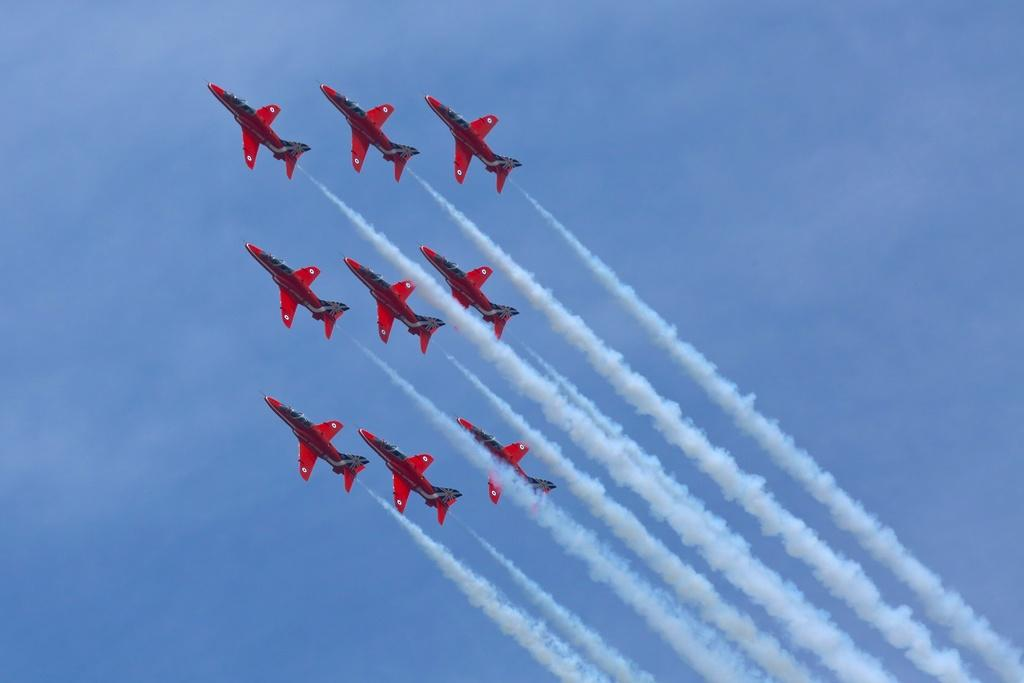What event is taking place in the image? There is an air show in the image. How many aircrafts can be seen during the event? Nine aircrafts are present in the image. What is visible part of the environment is shown in the image? The sky is visible at the top of the image. What type of scissors are being used to cut the birthday cake in the image? There is no birthday cake or scissors present in the image; it features an air show with aircrafts. How much sand can be seen on the beach in the image? There is no beach or sand present in the image; it features an air show with aircrafts and a visible sky. 